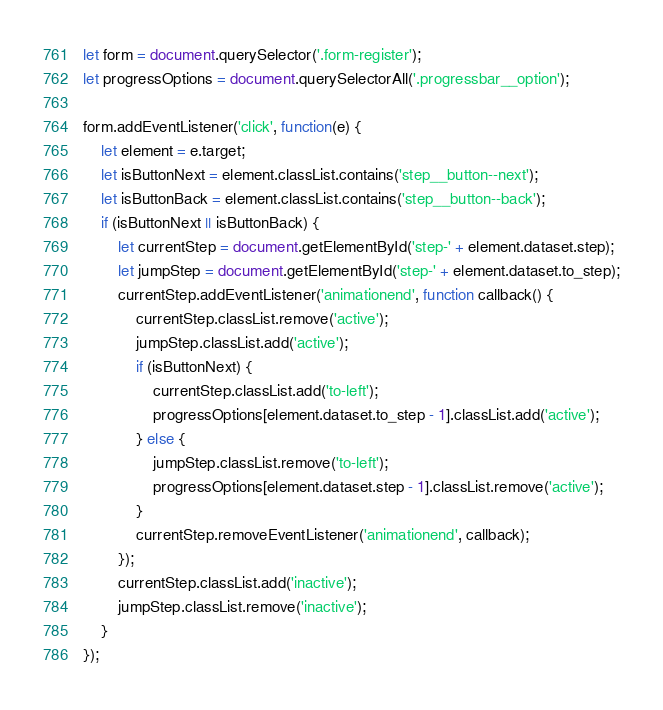<code> <loc_0><loc_0><loc_500><loc_500><_JavaScript_>let form = document.querySelector('.form-register');
let progressOptions = document.querySelectorAll('.progressbar__option');

form.addEventListener('click', function(e) {
    let element = e.target;
    let isButtonNext = element.classList.contains('step__button--next');
    let isButtonBack = element.classList.contains('step__button--back');
    if (isButtonNext || isButtonBack) {
        let currentStep = document.getElementById('step-' + element.dataset.step);
        let jumpStep = document.getElementById('step-' + element.dataset.to_step);
        currentStep.addEventListener('animationend', function callback() {
            currentStep.classList.remove('active');
            jumpStep.classList.add('active');
            if (isButtonNext) {
                currentStep.classList.add('to-left');
                progressOptions[element.dataset.to_step - 1].classList.add('active');
            } else {
                jumpStep.classList.remove('to-left');
                progressOptions[element.dataset.step - 1].classList.remove('active');
            }
            currentStep.removeEventListener('animationend', callback);
        });
        currentStep.classList.add('inactive');
        jumpStep.classList.remove('inactive');
    }
});</code> 